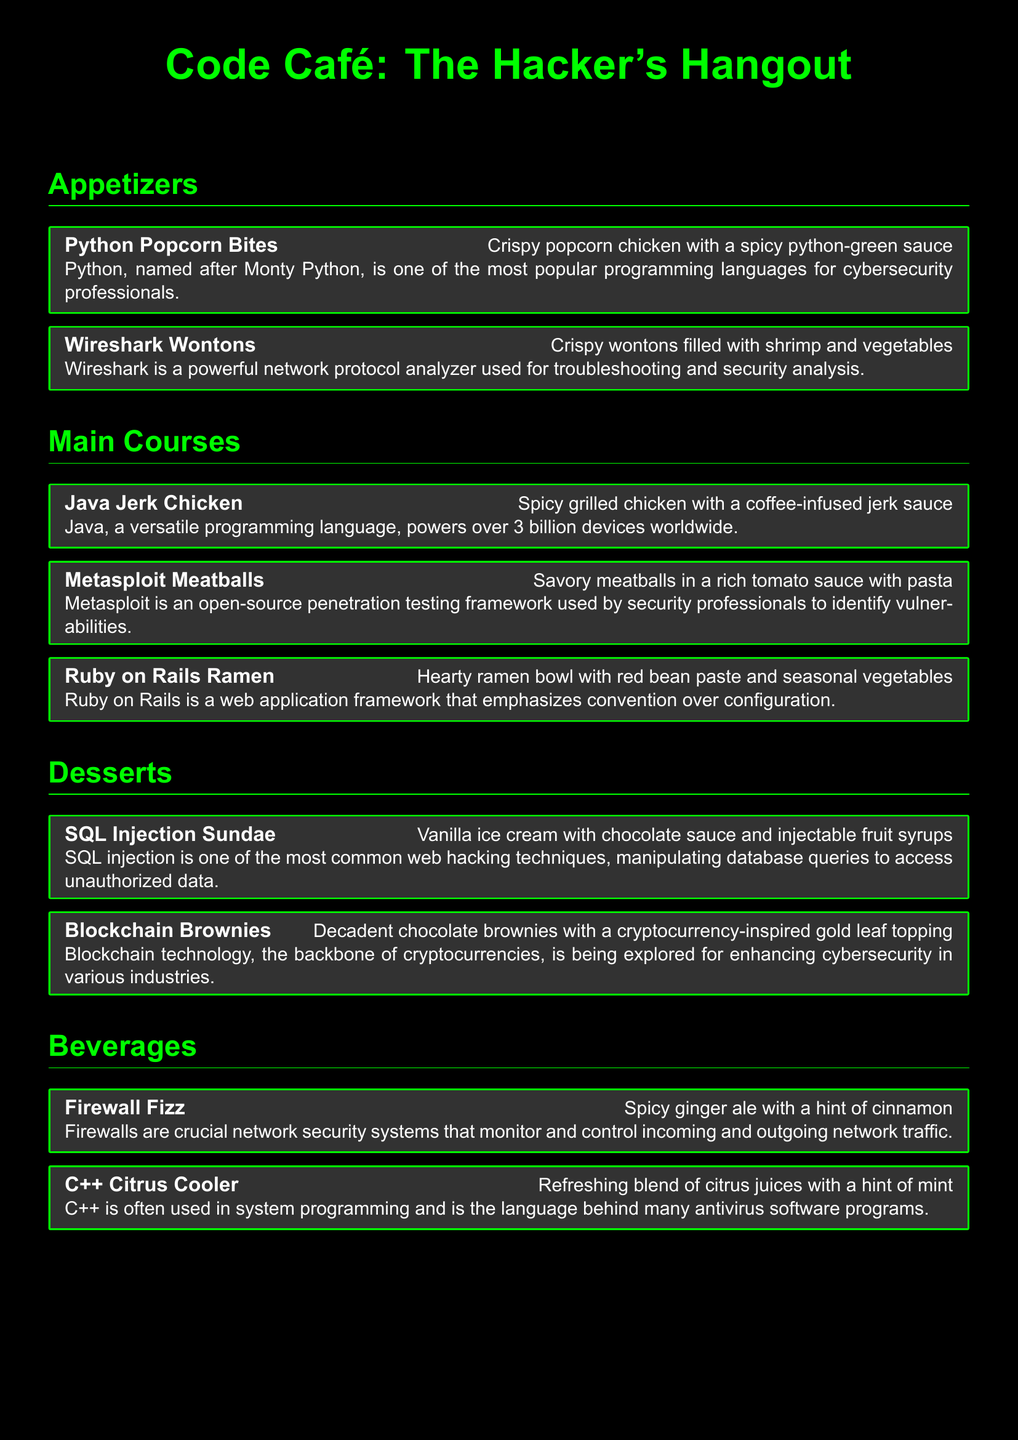What is the name of the spicy chicken dish? The spicy chicken dish is called “Java Jerk Chicken.”
Answer: Java Jerk Chicken What dessert has chocolate sauce? The dessert that has chocolate sauce is the “SQL Injection Sundae.”
Answer: SQL Injection Sundae How many appetizers are listed on the menu? There are two appetizers listed on the menu: “Python Popcorn Bites” and “Wireshark Wontons.”
Answer: Two What programming language is the “Blockhain Brownies” named after? The “Blockchain Brownies” are named after blockchain technology.
Answer: Blockchain Which beverage is inspired by a network security system? The beverage inspired by a network security system is called “Firewall Fizz.”
Answer: Firewall Fizz What type of dish is “Metasploit Meatballs”? “Metasploit Meatballs” is categorized under “Main Courses.”
Answer: Main Courses What ingredient is in the “C++ Citrus Cooler”? The “C++ Citrus Cooler” contains a blend of citrus juices.
Answer: Citrus juices What is the main feature of the “Ruby on Rails Ramen”? The main feature of the “Ruby on Rails Ramen” is seasonal vegetables.
Answer: Seasonal vegetables Which programming language powers over 3 billion devices? The programming language that powers over 3 billion devices is “Java.”
Answer: Java 